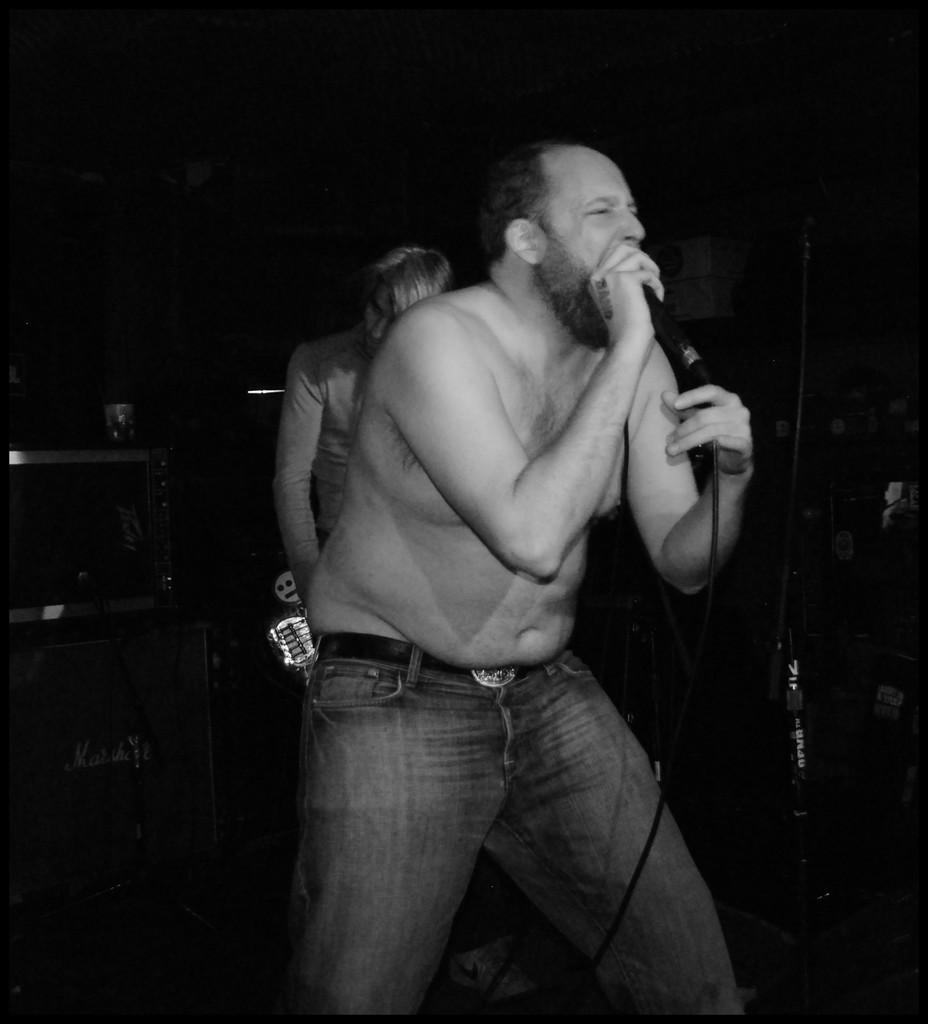Who is the main subject in the image? There is a man in the image. What is the man wearing? The man is wearing blue jeans. What is the man holding in the image? The man is holding a microphone. Can you describe the other person in the image? There is another person in the background of the image. What type of volleyball is the man playing in the image? There is no volleyball present in the image; the man is holding a microphone. How many oranges can be seen in the image? There are no oranges present in the image. 